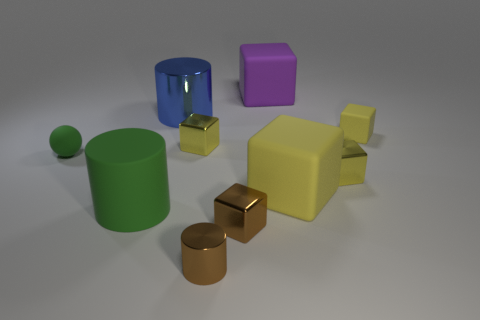Subtract all yellow blocks. How many were subtracted if there are2yellow blocks left? 2 Subtract all yellow spheres. How many yellow cubes are left? 4 Subtract all brown blocks. How many blocks are left? 5 Subtract 3 cubes. How many cubes are left? 3 Subtract all small yellow rubber blocks. How many blocks are left? 5 Subtract all red cubes. Subtract all purple cylinders. How many cubes are left? 6 Subtract all spheres. How many objects are left? 9 Add 6 large rubber cubes. How many large rubber cubes are left? 8 Add 7 brown cylinders. How many brown cylinders exist? 8 Subtract 1 purple cubes. How many objects are left? 9 